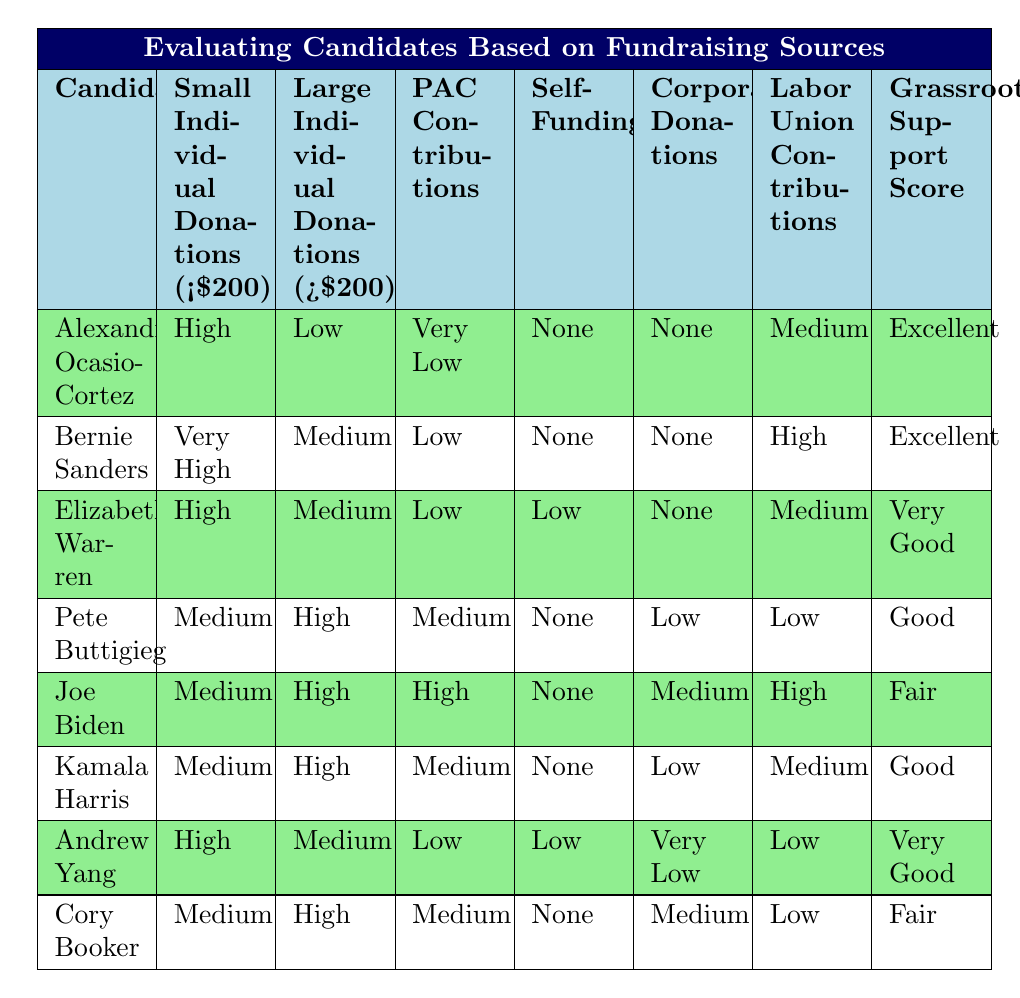What is the Grassroots Support Score for Alexandria Ocasio-Cortez? The Grassroots Support Score for Alexandria Ocasio-Cortez is listed as "Excellent" in the table.
Answer: Excellent Which candidate has the highest Small Individual Donations? Bernie Sanders has the highest Small Individual Donations rated as "Very High" in the table.
Answer: Bernie Sanders Is it true that Joe Biden has a "Low" Grassroots Support Score? No, Joe Biden has a Grassroots Support Score of "Fair," which is not classified as "Low" in the table.
Answer: No How many candidates received "None" for Self-Funding? Three candidates (Alexandria Ocasio-Cortez, Bernie Sanders, and Pete Buttigieg) received "None" for Self-Funding.
Answer: Three What is the difference in Large Individual Donations between Kamala Harris and Andrew Yang? Both candidates have "High" and "Medium" for Large Individual Donations respectively, creating a difference of one category. Kamala Harris is at "High" while Andrew Yang is at "Medium."
Answer: One category Which candidate has medium Labor Union Contributions and a Good Grassroots Support Score? Pete Buttigieg has "Low" for Labor Union Contributions and a "Good" Grassroots Support Score.
Answer: Pete Buttigieg What type of contributions does Cory Booker have in terms of Corporate Donations? Cory Booker has "Medium" for Corporate Donations according to the data presented in the table, indicating a balanced approach to funding.
Answer: Medium How does the Grassroots Support Score of Elizabeth Warren compare to that of Joe Biden? Elizabeth Warren's Grassroots Support Score is "Very Good", which is one level higher than Joe Biden's "Fair" score, meaning Warren has stronger grassroots support.
Answer: One level higher 